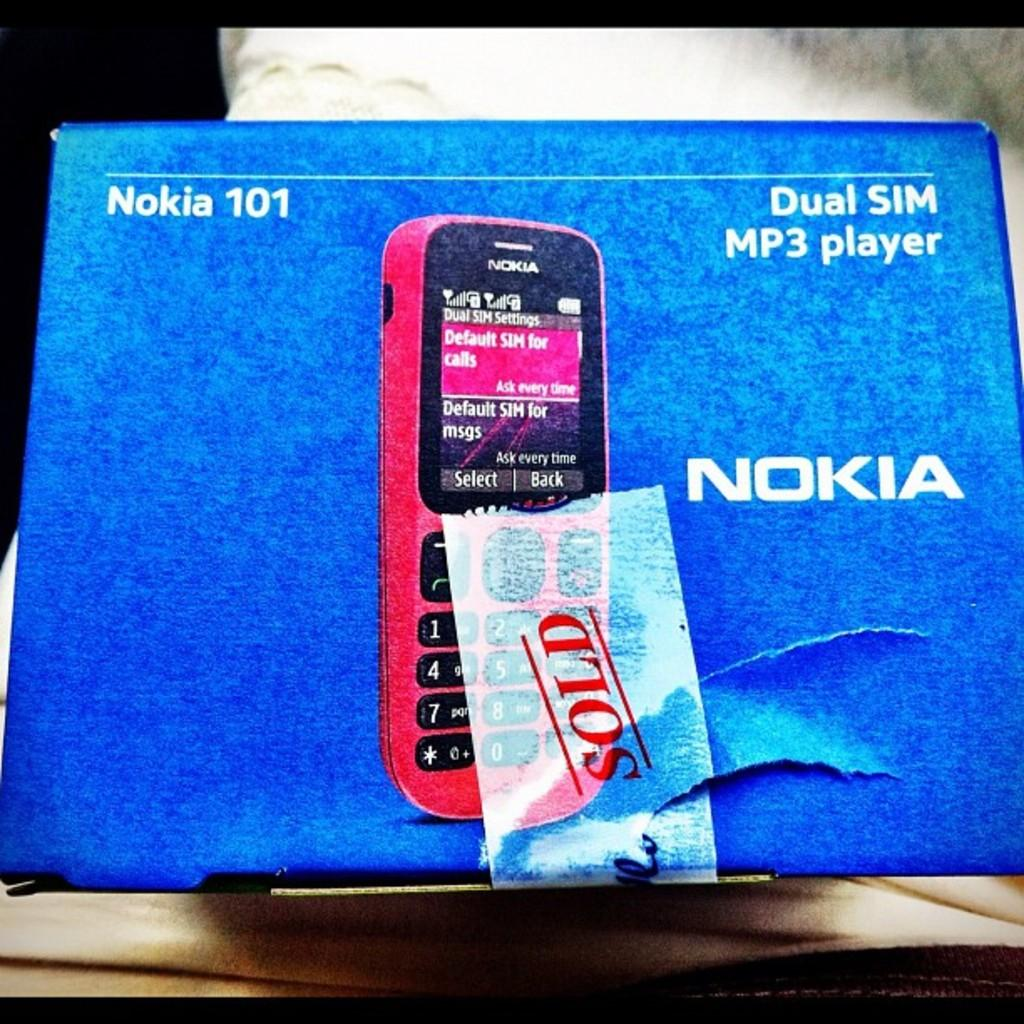<image>
Offer a succinct explanation of the picture presented. A box for a red Nokia MP3 player with dual SIM compatibility. 